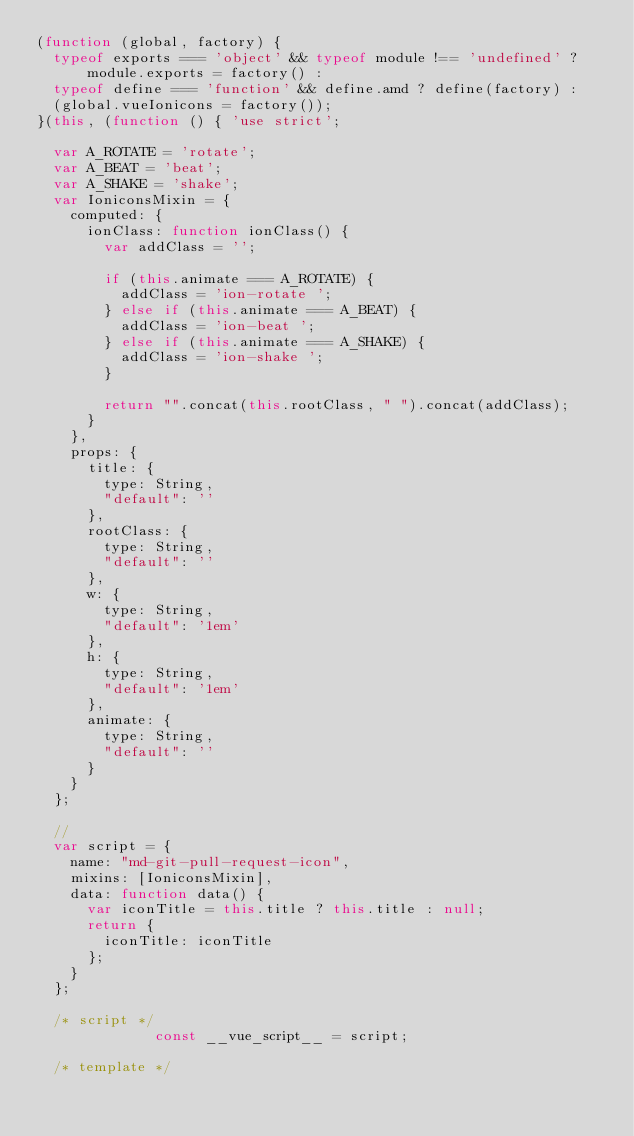Convert code to text. <code><loc_0><loc_0><loc_500><loc_500><_JavaScript_>(function (global, factory) {
  typeof exports === 'object' && typeof module !== 'undefined' ? module.exports = factory() :
  typeof define === 'function' && define.amd ? define(factory) :
  (global.vueIonicons = factory());
}(this, (function () { 'use strict';

  var A_ROTATE = 'rotate';
  var A_BEAT = 'beat';
  var A_SHAKE = 'shake';
  var IoniconsMixin = {
    computed: {
      ionClass: function ionClass() {
        var addClass = '';

        if (this.animate === A_ROTATE) {
          addClass = 'ion-rotate ';
        } else if (this.animate === A_BEAT) {
          addClass = 'ion-beat ';
        } else if (this.animate === A_SHAKE) {
          addClass = 'ion-shake ';
        }

        return "".concat(this.rootClass, " ").concat(addClass);
      }
    },
    props: {
      title: {
        type: String,
        "default": ''
      },
      rootClass: {
        type: String,
        "default": ''
      },
      w: {
        type: String,
        "default": '1em'
      },
      h: {
        type: String,
        "default": '1em'
      },
      animate: {
        type: String,
        "default": ''
      }
    }
  };

  //
  var script = {
    name: "md-git-pull-request-icon",
    mixins: [IoniconsMixin],
    data: function data() {
      var iconTitle = this.title ? this.title : null;
      return {
        iconTitle: iconTitle
      };
    }
  };

  /* script */
              const __vue_script__ = script;
              
  /* template */</code> 